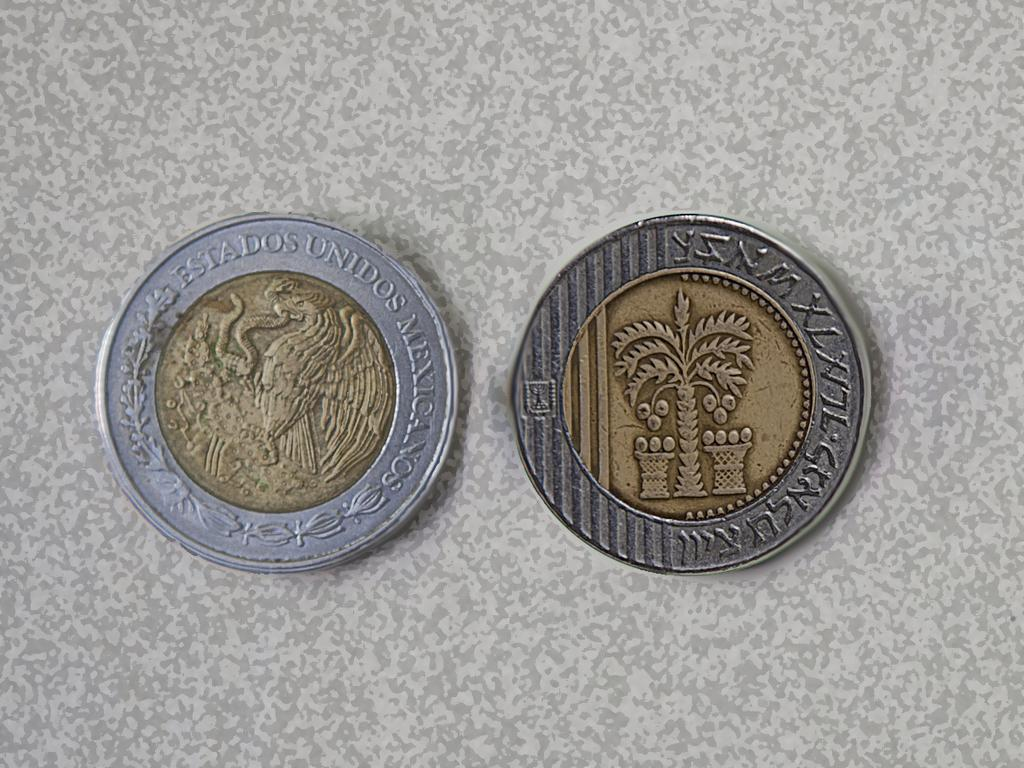<image>
Relay a brief, clear account of the picture shown. The silver coin on the table reads Estados on it 